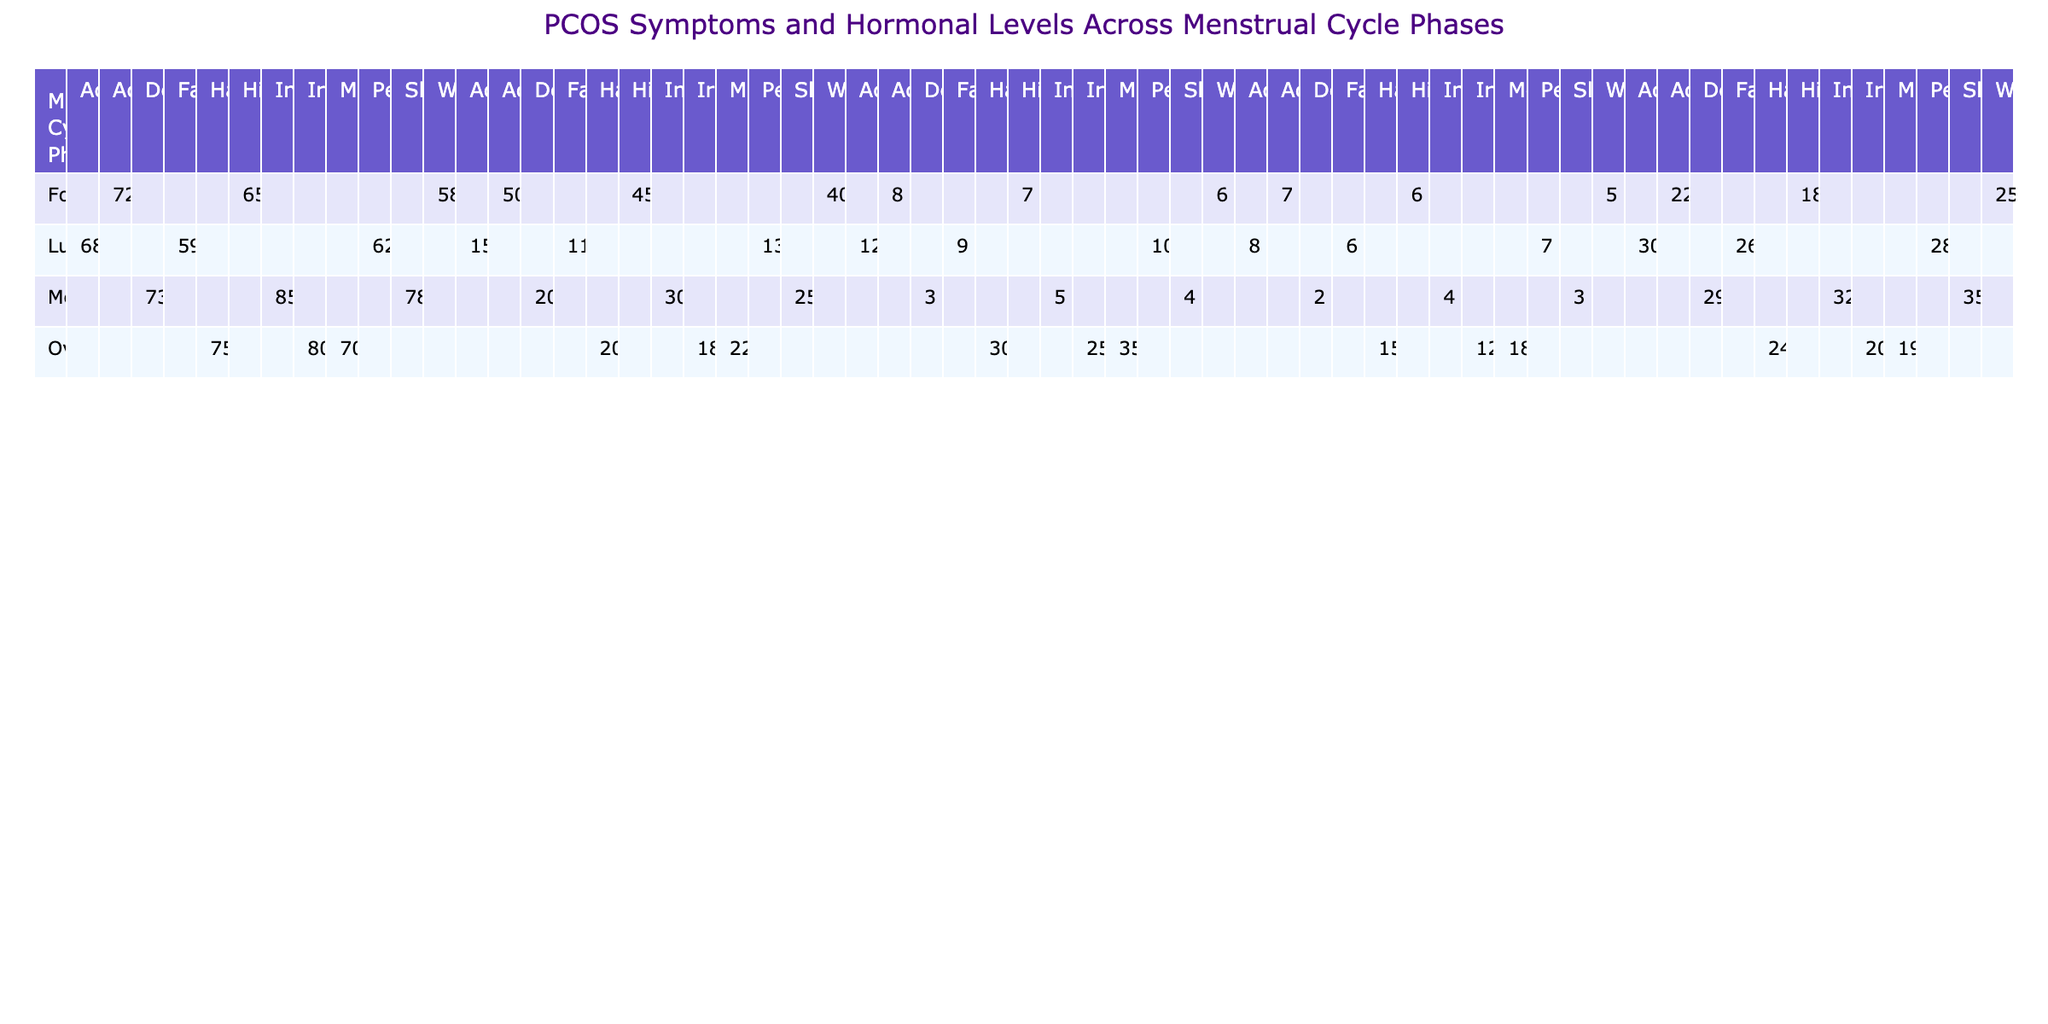What is the testosterone level during the ovulatory phase for hair loss? The table shows that during the ovulatory phase, the testosterone level for hair loss is 75.
Answer: 75 What is the estradiol level for pelvic pain in the luteal phase? According to the table, the estradiol level for pelvic pain in the luteal phase is 130.
Answer: 130 Which symptom during the menstrual phase has the highest insulin level? By examining the table, infertility has the highest insulin level of 32 among the symptoms listed for the menstrual phase.
Answer: Infertility What is the average testosterone level across all menstrual cycle phases? The testosterone levels are 65, 72, 58, 80, 75, 70, 68, 62, 59, 85, 78, and 73. Adding them gives  876, and dividing by 12 results in an average of 73.
Answer: 73 Is there any symptom during the follicular phase that has an insulin level higher than 20? The insulin levels for hirsutism, acne, and weight gain in the follicular phase are 18, 22, and 25 respectively. Therefore, acne and weight gain show insulin levels higher than 20.
Answer: Yes What is the difference in estradiol levels between the ovulatory phase and the luteal phase for mood swings? The estradiol level for mood swings in the ovulatory phase is 220, and in the luteal phase, it is 150. The difference is 220 - 150 = 70.
Answer: 70 In which phase is hirsutism most closely associated with the lowest insulin level? The table shows that during the follicular phase, hirsutism has the lowest insulin level of 18 compared to other phases.
Answer: Follicular What condition has the second highest LH level, and in which phase does it occur? The LH levels for the symptoms are 7, 8, 25, 30, 35, 12, 10, 9, 5, 4, 3, and 4 respectively. The second highest LH level is 30 for hair loss in the ovulatory phase.
Answer: Hair loss, Ovulatory phase Is the testosterone level for acne greater than the testosterone level for fatigue? The testosterone levels for acne and fatigue are 72 and 59, respectively. Since 72 is greater than 59, the statement is true.
Answer: Yes What is the total number of symptoms recorded during the luteal phase? The luteal phase has three symptoms listed: acanthosis nigricans, pelvic pain, and fatigue. Thus, the total is three symptoms.
Answer: 3 